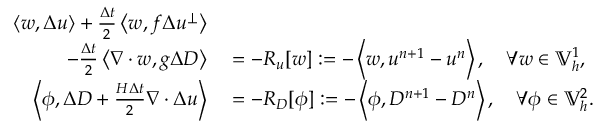<formula> <loc_0><loc_0><loc_500><loc_500>\begin{array} { r l } { \left \langle w , \Delta u \right \rangle + \frac { \Delta t } { 2 } \left \langle w , f \Delta u ^ { \perp } \right \rangle } \\ { \quad - \frac { \Delta t } { 2 } \left \langle \nabla \cdot w , g \Delta D \right \rangle } & = - R _ { u } [ w ] \colon = - \left \langle w , u ^ { n + 1 } - u ^ { n } \right \rangle , \quad \forall w \in \mathbb { V } _ { h } ^ { 1 } , } \\ { \left \langle \phi , \Delta D + \frac { H \Delta t } { 2 } \nabla \cdot \Delta u \right \rangle } & = - R _ { D } [ \phi ] \colon = - \left \langle \phi , D ^ { n + 1 } - D ^ { n } \right \rangle , \quad \forall \phi \in \mathbb { V } _ { h } ^ { 2 } . } \end{array}</formula> 